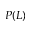<formula> <loc_0><loc_0><loc_500><loc_500>P ( L )</formula> 